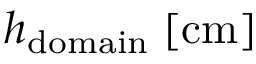<formula> <loc_0><loc_0><loc_500><loc_500>h _ { d o m a i n } \, [ c m ]</formula> 